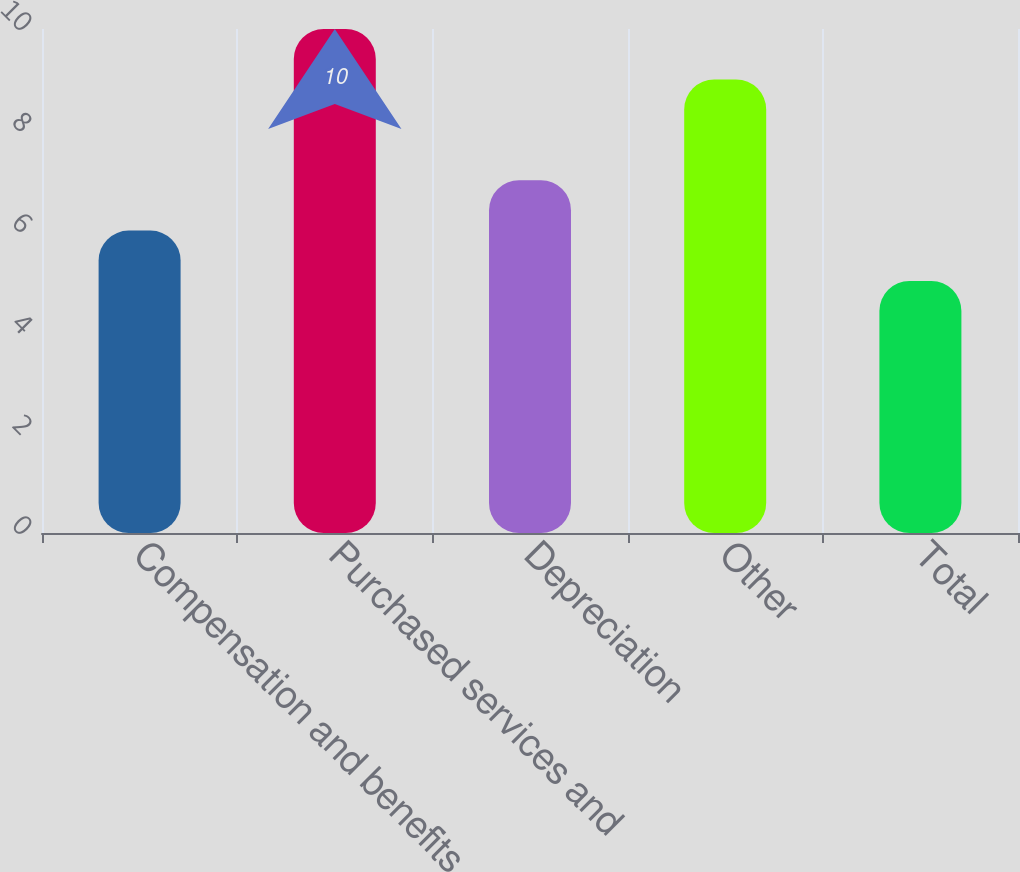<chart> <loc_0><loc_0><loc_500><loc_500><bar_chart><fcel>Compensation and benefits<fcel>Purchased services and<fcel>Depreciation<fcel>Other<fcel>Total<nl><fcel>6<fcel>10<fcel>7<fcel>9<fcel>5<nl></chart> 